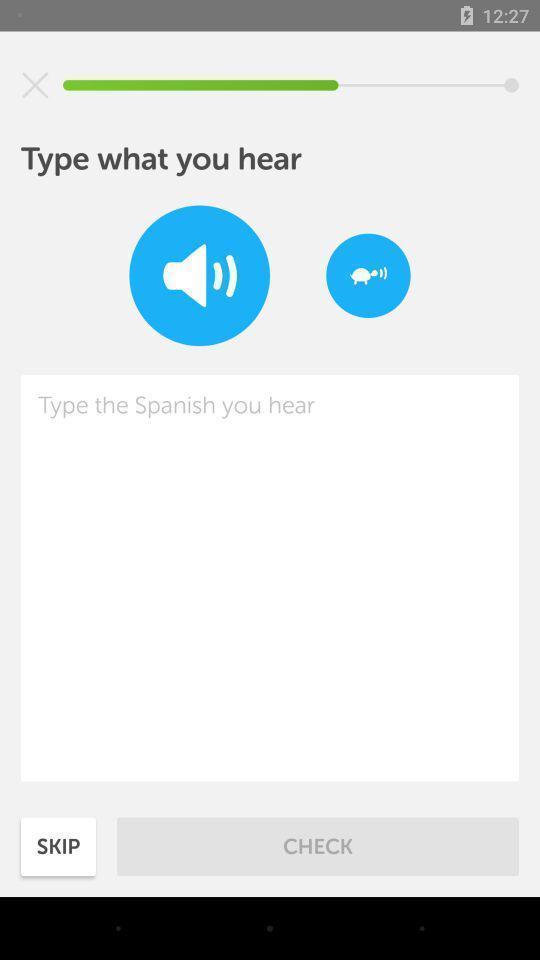Provide a description of this screenshot. Translator page. 